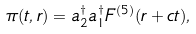Convert formula to latex. <formula><loc_0><loc_0><loc_500><loc_500>\pi ( t , r ) = a _ { 2 } ^ { \dagger } a _ { 1 } ^ { \dagger } F ^ { ( 5 ) } ( r + c t ) ,</formula> 